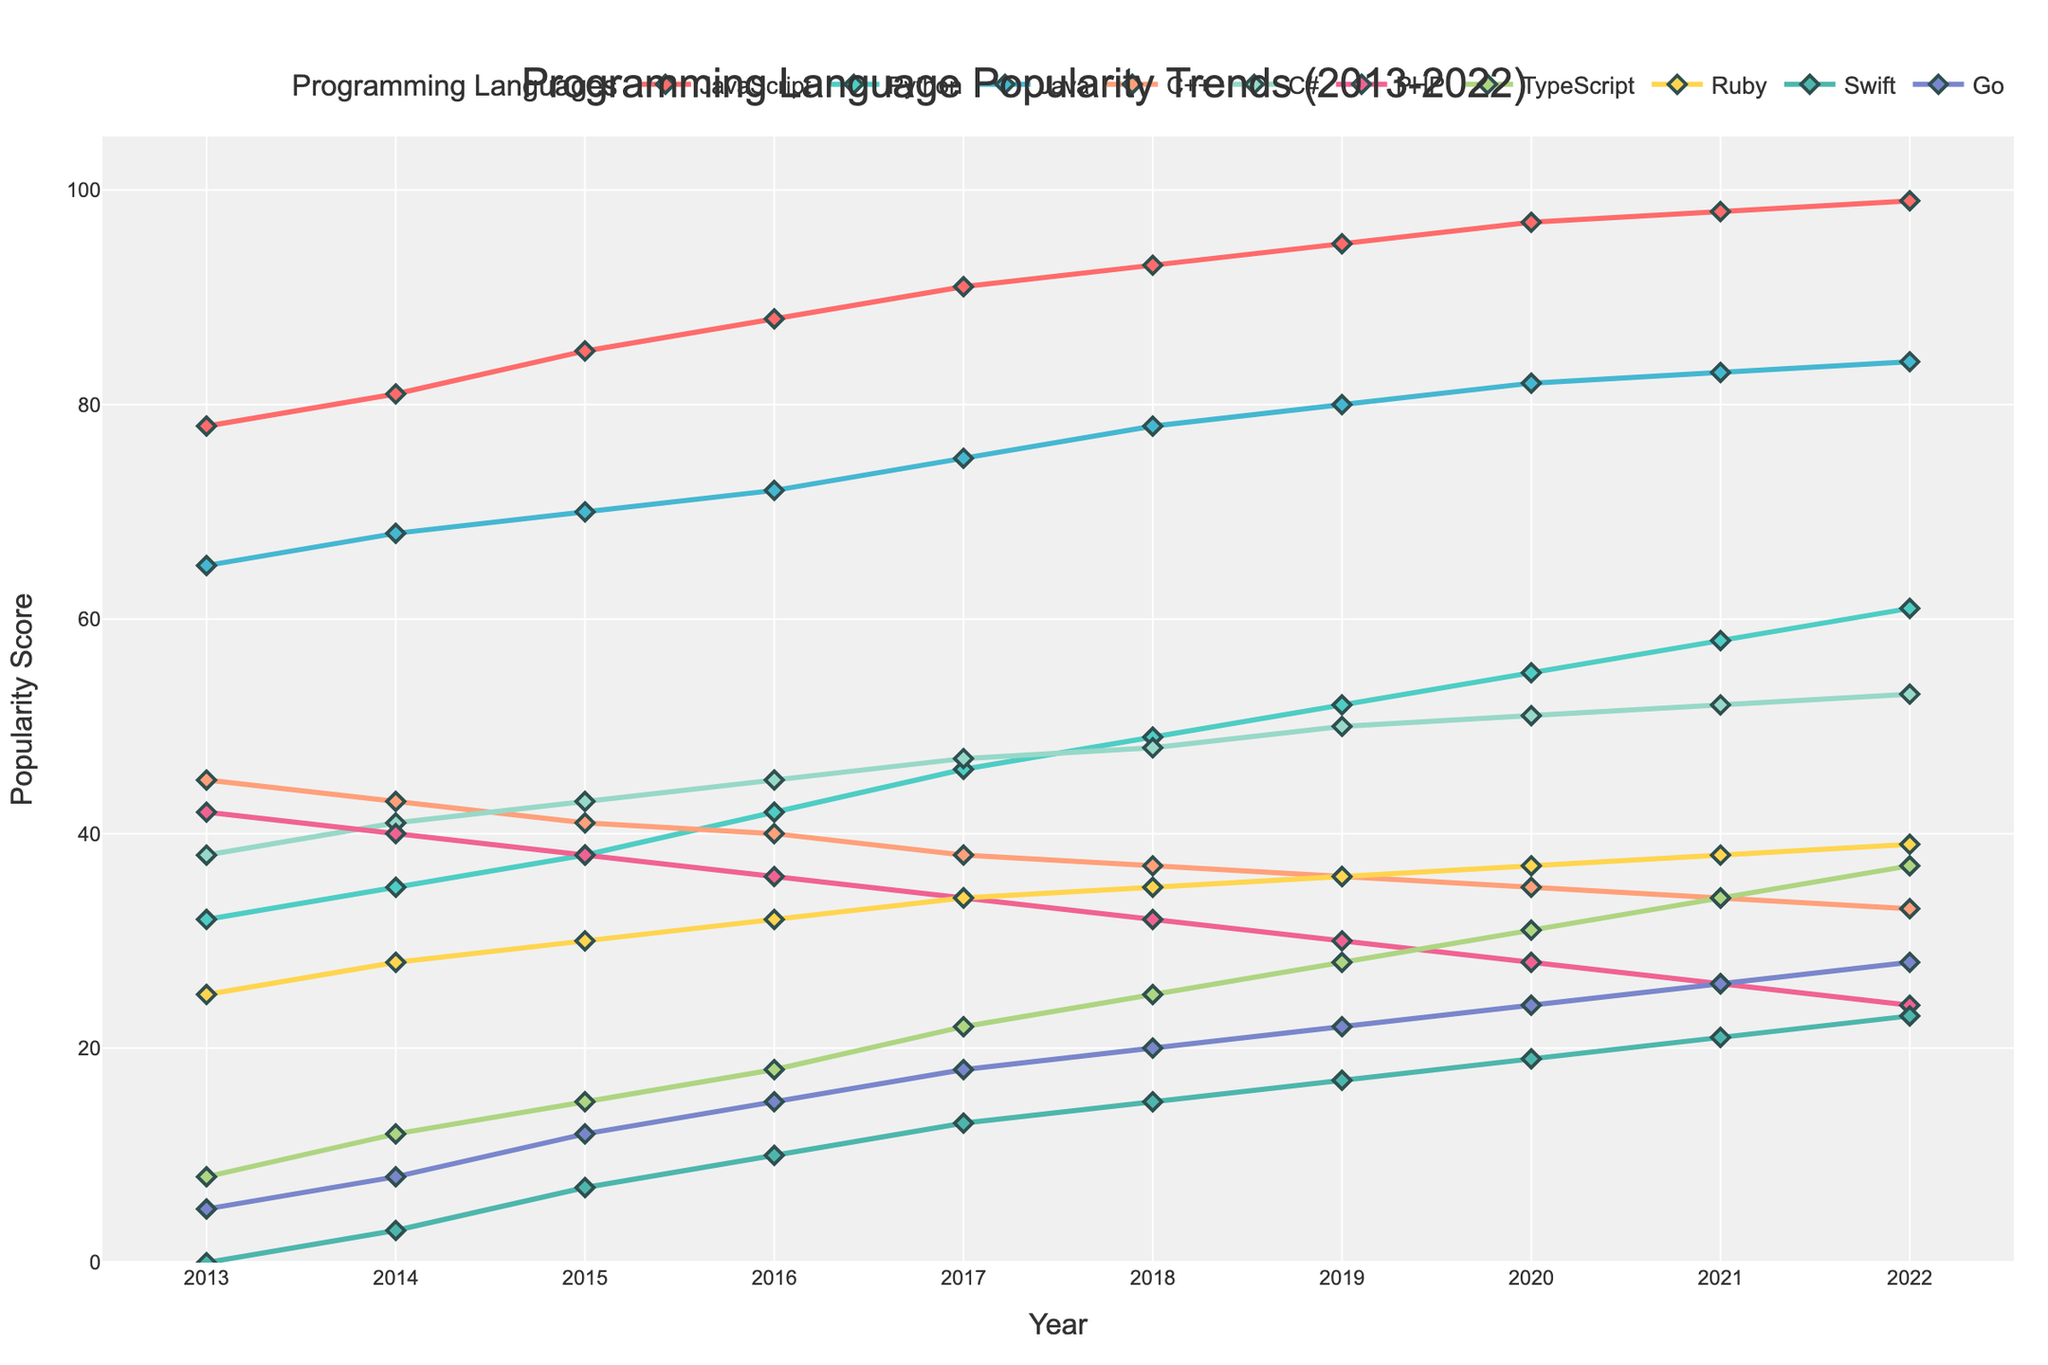Which programming language saw the largest increase in popularity from 2013 to 2022? First, note the values for each language in 2013 and 2022. Calculate the difference for each: JavaScript (99-78=21), Python (61-32=29), Java (84-65=19), C++ (33-45=-12), C# (53-38=15), PHP (24-42=-18), TypeScript (37-8=29), Ruby (39-25=14), Swift (23-0=23), Go (28-5=23). Python and TypeScript have the largest increases (29 each).
Answer: Python and TypeScript Which language had the smallest increase in popularity from 2013 to 2022? Calculate the difference for each language from 2013 to 2022: JavaScript (99-78=21), Python (61-32=29), Java (84-65=19), C++ (33-45=-12), C# (53-38=15), PHP (24-42=-18), TypeScript (37-8=29), Ruby (39-25=14), Swift (23-0=23), Go (28-5=23). C++ and PHP had declines (-12 and -18 respectively), indicating negative changes. PHP has the smallest increase (since it decreased the most).
Answer: PHP Which languages have consistently increased their popularity every year from 2013 to 2022? Observe the plot for each language's yearly trend; only consider languages whose data points increase or stay the same yearly. JavaScript, Python, TypeScript, and Go show consistent increases.
Answer: JavaScript, Python, TypeScript, Go What was the difference in popularity between JavaScript and TypeScript in 2022? The value for JavaScript in 2022 is 99 and for TypeScript is 37. Calculate the difference: 99 - 37 = 62.
Answer: 62 Which language had the highest popularity score in any given year, and what was the score? Look for the highest peak in the trend lines for all languages. JavaScript consistently peaks at 99 in 2022.
Answer: JavaScript, 99 In which year did Go overtake Ruby in popularity? Track the trend lines for Go and Ruby. Go surpassed Ruby in 2018 with a score of 20 compared to Ruby's 19.
Answer: 2018 Which language increased the most in popularity between 2019 and 2020? Calculate the differences: JavaScript (97-95=2), Python (55-52=3), Java (82-80=2), C++ (35-36=-1), C# (51-50=1), PHP (28-30=-2), TypeScript (31-28=3), Ruby (37-36=1), Swift (19-17=2), Go (24-22=2). Python and TypeScript show the highest increase of 3.
Answer: Python and TypeScript What are the top three most popular languages in 2022? Look at the 2022 data points. The top three are JavaScript (99), Python (61), and Java (84).
Answer: JavaScript, Python, Java How did the popularity of Swift change from its introduction to 2022? Observe the trend line for Swift starting from 2014 (3) to 2022 (23). Calculate the difference: 23 - 3 = 20.
Answer: Increased by 20 What is the average popularity of Python over the decade? Add the values for Python for each year and divide by the number of years: (32+35+38+42+46+49+52+55+58+61)/10 = 46.8.
Answer: 46.8 